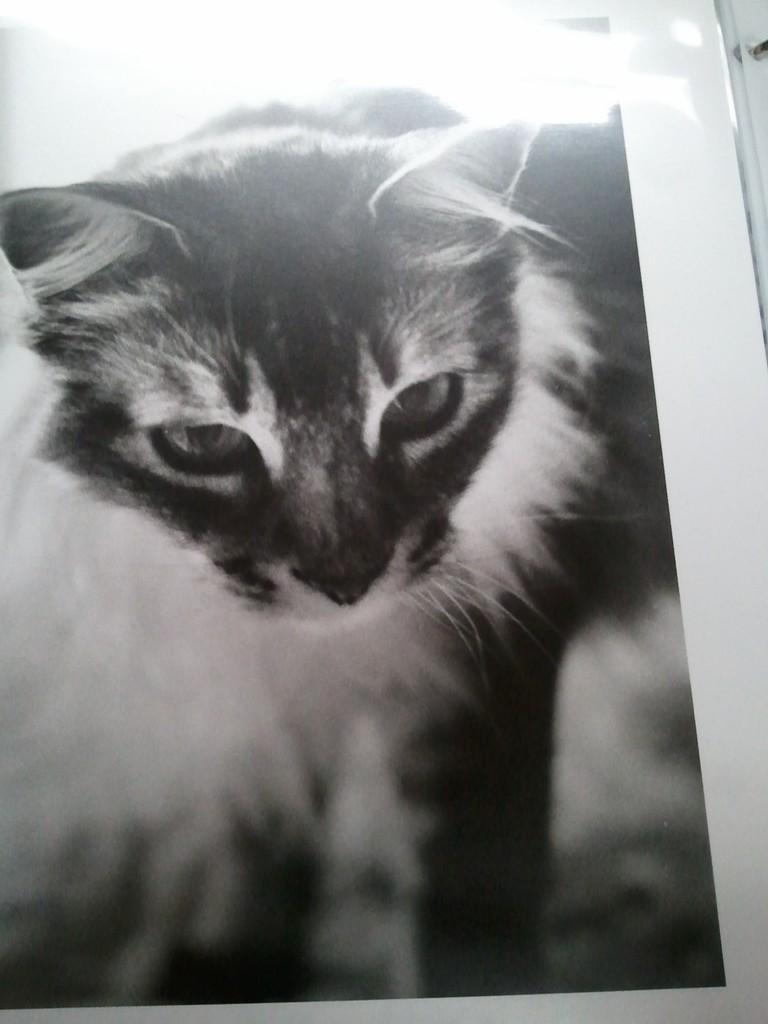Can you describe this image briefly? This is a black and white image. In this image there is a paper. On that there is a cat. 